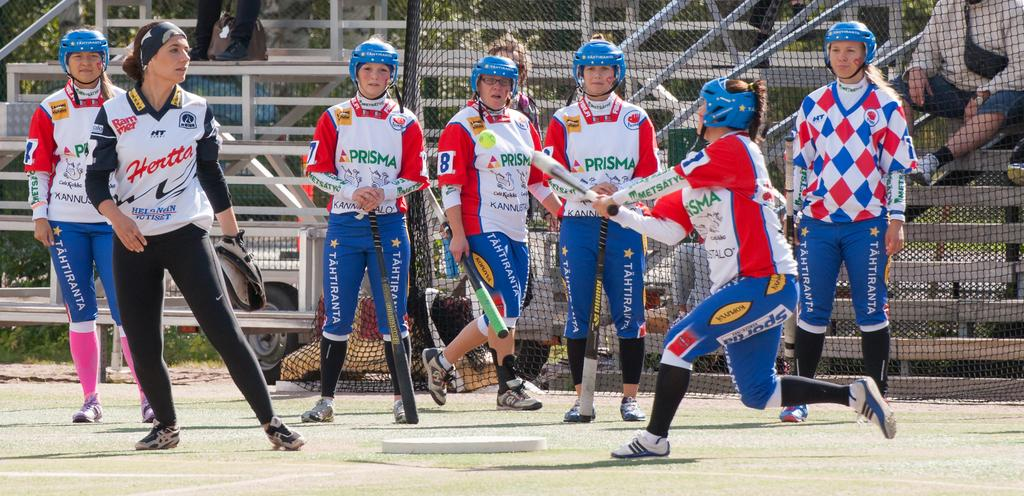<image>
Describe the image concisely. women in a baseball league with one wearing a shirt that says 'hertta' 